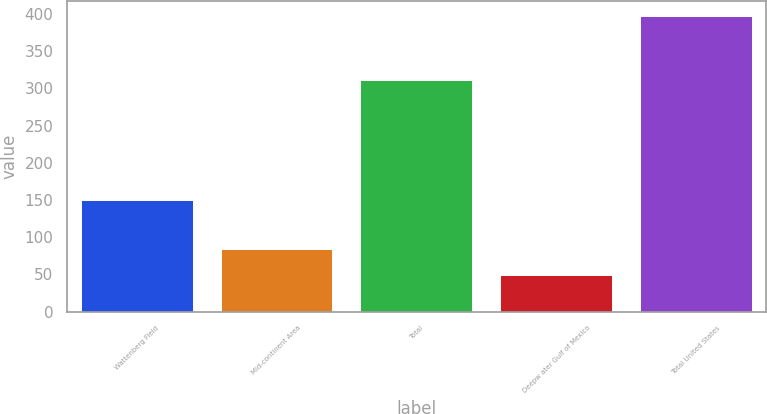<chart> <loc_0><loc_0><loc_500><loc_500><bar_chart><fcel>Wattenberg Field<fcel>Mid-continent Area<fcel>Total<fcel>Deepw ater Gulf of Mexico<fcel>Total United States<nl><fcel>150<fcel>83.8<fcel>311<fcel>49<fcel>397<nl></chart> 